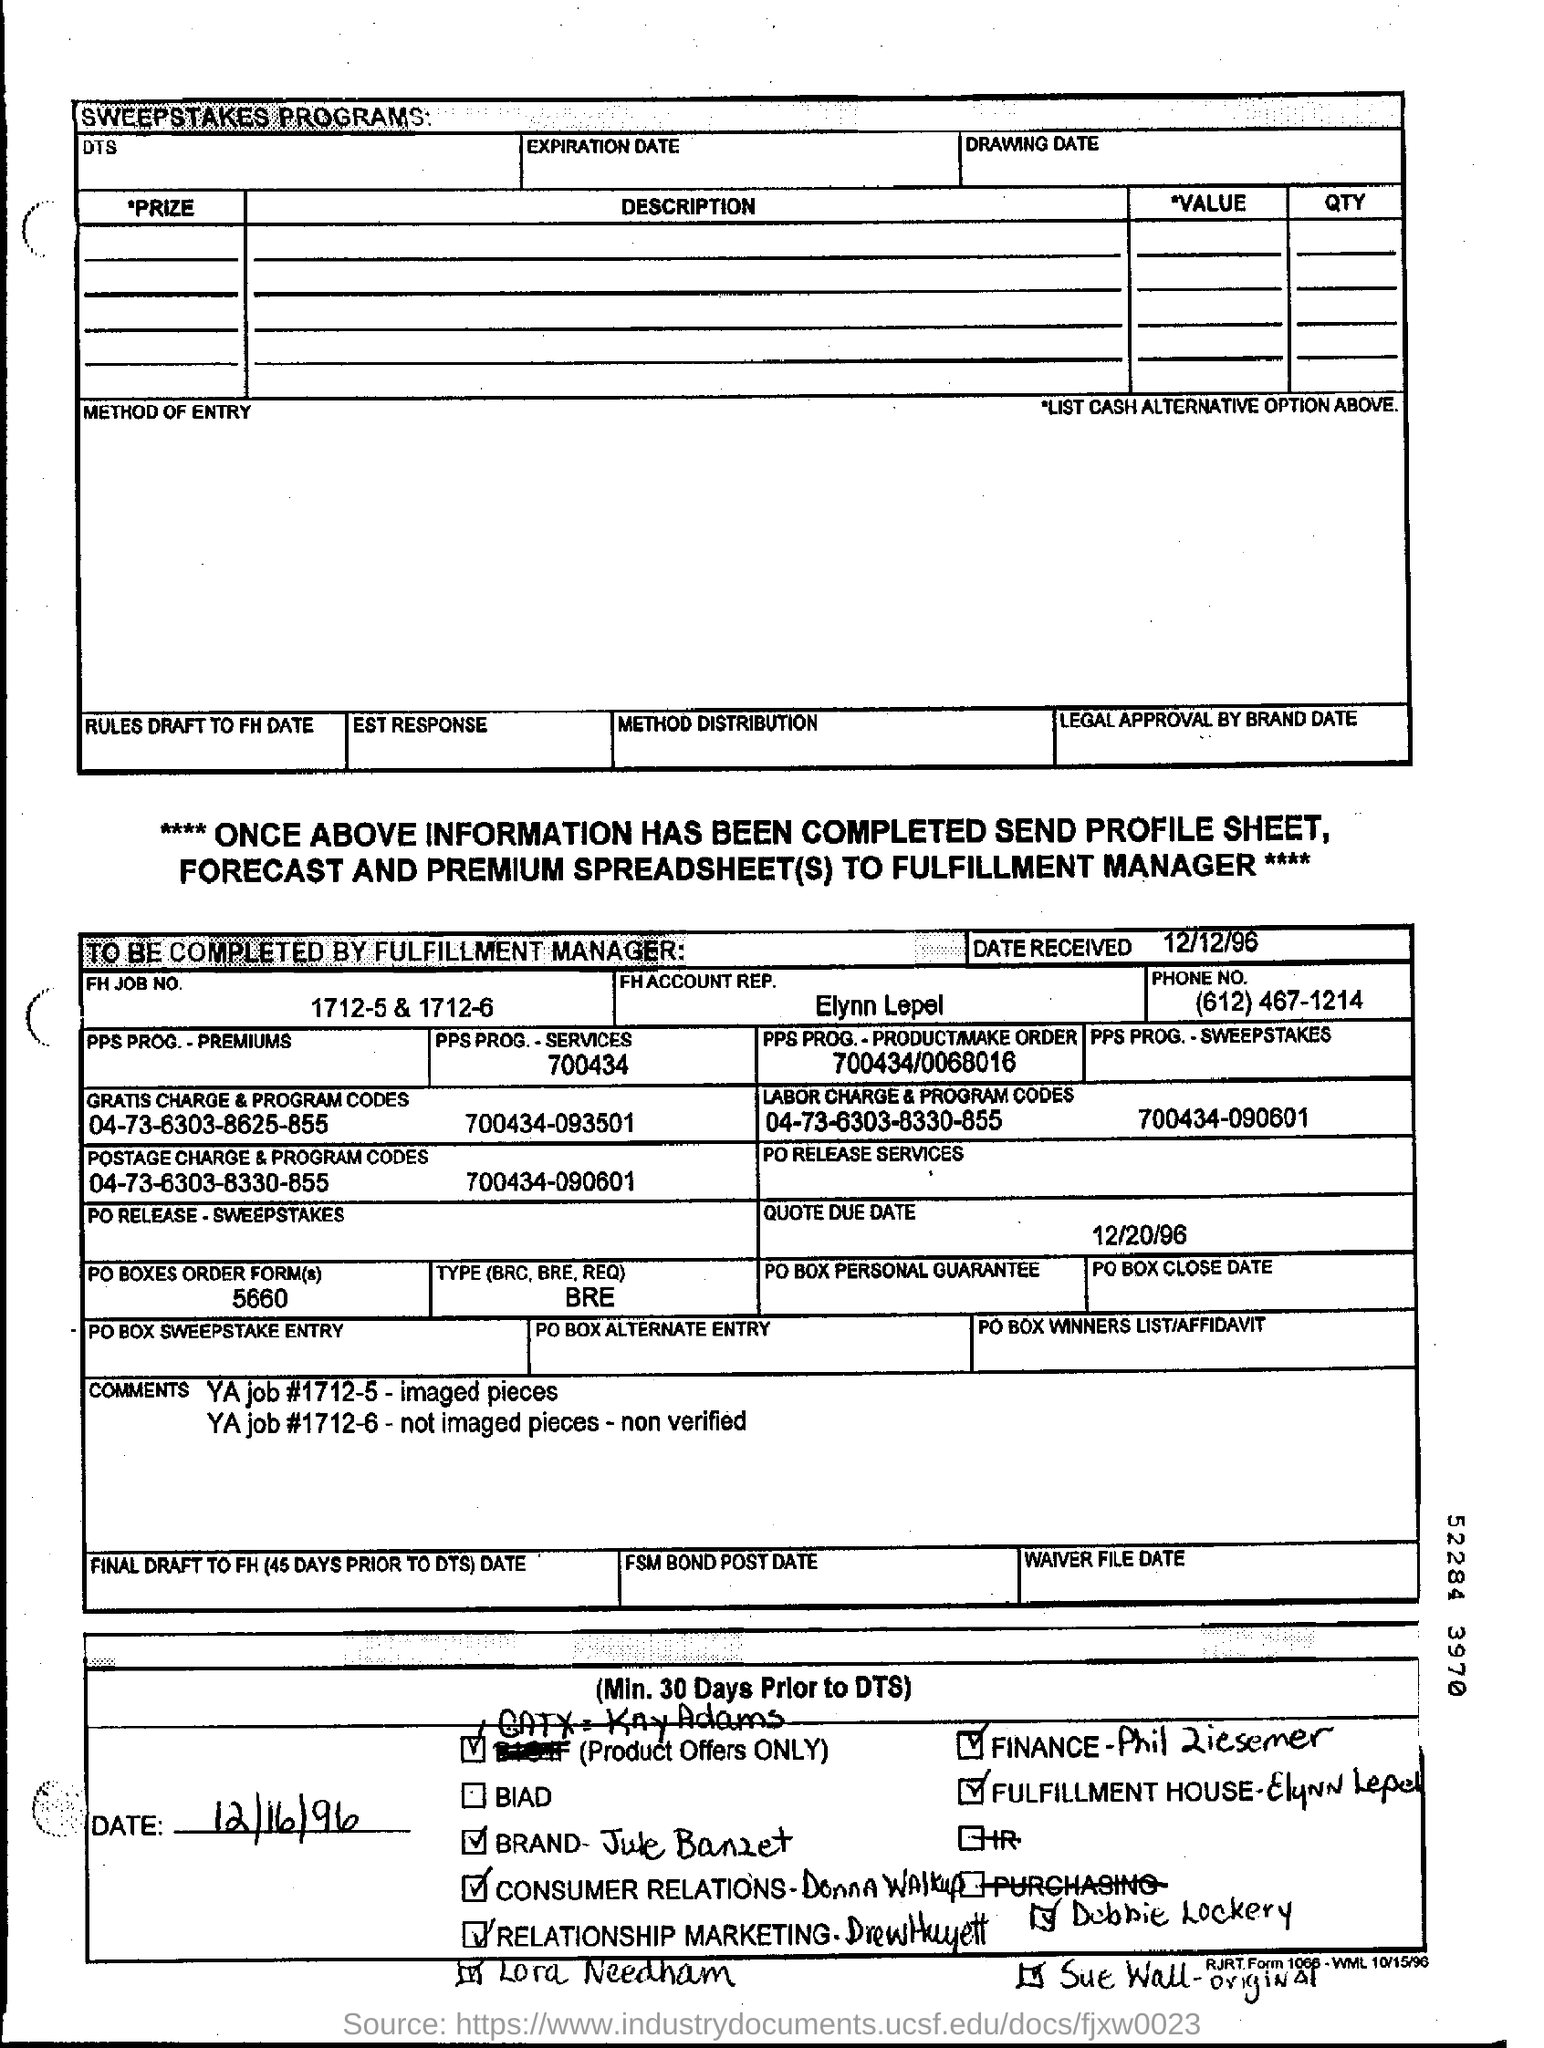What is received date mentioned in the document?
Your answer should be very brief. 12/12/96. What is the FH Job No. mentioned in this document?
Offer a very short reply. 1712-5 & 1712-6. What is the due date mentioned in the document?
Provide a succinct answer. 12/20/96. 